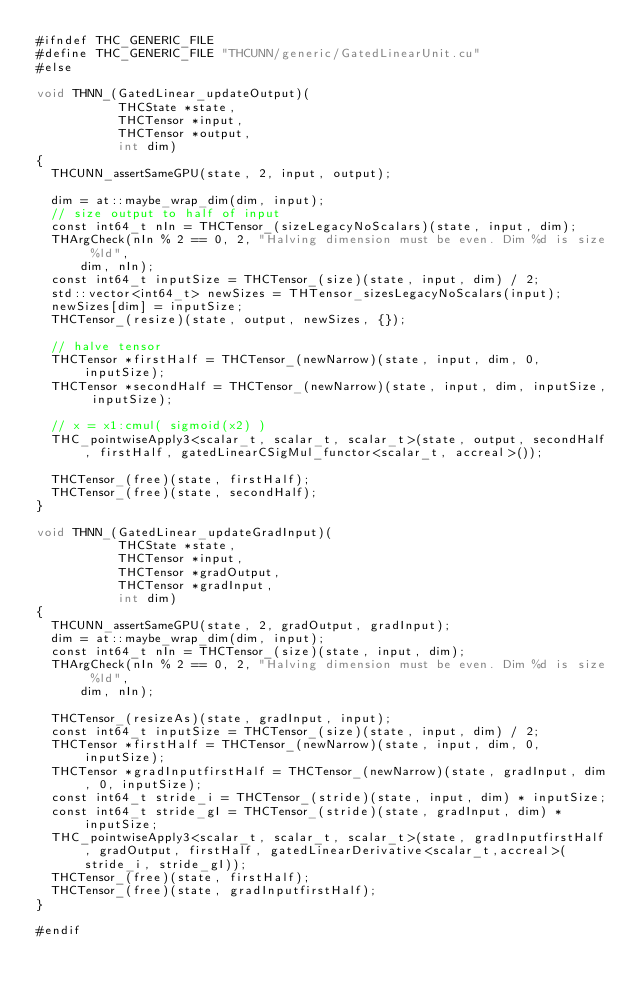<code> <loc_0><loc_0><loc_500><loc_500><_Cuda_>#ifndef THC_GENERIC_FILE
#define THC_GENERIC_FILE "THCUNN/generic/GatedLinearUnit.cu"
#else

void THNN_(GatedLinear_updateOutput)(
           THCState *state,
           THCTensor *input,
           THCTensor *output,
           int dim)
{
  THCUNN_assertSameGPU(state, 2, input, output);

  dim = at::maybe_wrap_dim(dim, input);
  // size output to half of input
  const int64_t nIn = THCTensor_(sizeLegacyNoScalars)(state, input, dim);
  THArgCheck(nIn % 2 == 0, 2, "Halving dimension must be even. Dim %d is size %ld",
      dim, nIn);
  const int64_t inputSize = THCTensor_(size)(state, input, dim) / 2;
  std::vector<int64_t> newSizes = THTensor_sizesLegacyNoScalars(input);
  newSizes[dim] = inputSize;
  THCTensor_(resize)(state, output, newSizes, {});

  // halve tensor
  THCTensor *firstHalf = THCTensor_(newNarrow)(state, input, dim, 0, inputSize);
  THCTensor *secondHalf = THCTensor_(newNarrow)(state, input, dim, inputSize, inputSize);

  // x = x1:cmul( sigmoid(x2) )
  THC_pointwiseApply3<scalar_t, scalar_t, scalar_t>(state, output, secondHalf, firstHalf, gatedLinearCSigMul_functor<scalar_t, accreal>());

  THCTensor_(free)(state, firstHalf);
  THCTensor_(free)(state, secondHalf);
}

void THNN_(GatedLinear_updateGradInput)(
           THCState *state,
           THCTensor *input,
           THCTensor *gradOutput,
           THCTensor *gradInput,
           int dim)
{
  THCUNN_assertSameGPU(state, 2, gradOutput, gradInput);
  dim = at::maybe_wrap_dim(dim, input);
  const int64_t nIn = THCTensor_(size)(state, input, dim);
  THArgCheck(nIn % 2 == 0, 2, "Halving dimension must be even. Dim %d is size %ld",
      dim, nIn);

  THCTensor_(resizeAs)(state, gradInput, input);
  const int64_t inputSize = THCTensor_(size)(state, input, dim) / 2;
  THCTensor *firstHalf = THCTensor_(newNarrow)(state, input, dim, 0, inputSize);
  THCTensor *gradInputfirstHalf = THCTensor_(newNarrow)(state, gradInput, dim, 0, inputSize);
  const int64_t stride_i = THCTensor_(stride)(state, input, dim) * inputSize;
  const int64_t stride_gI = THCTensor_(stride)(state, gradInput, dim) * inputSize;
  THC_pointwiseApply3<scalar_t, scalar_t, scalar_t>(state, gradInputfirstHalf, gradOutput, firstHalf, gatedLinearDerivative<scalar_t,accreal>(stride_i, stride_gI));
  THCTensor_(free)(state, firstHalf);
  THCTensor_(free)(state, gradInputfirstHalf);
}

#endif
</code> 